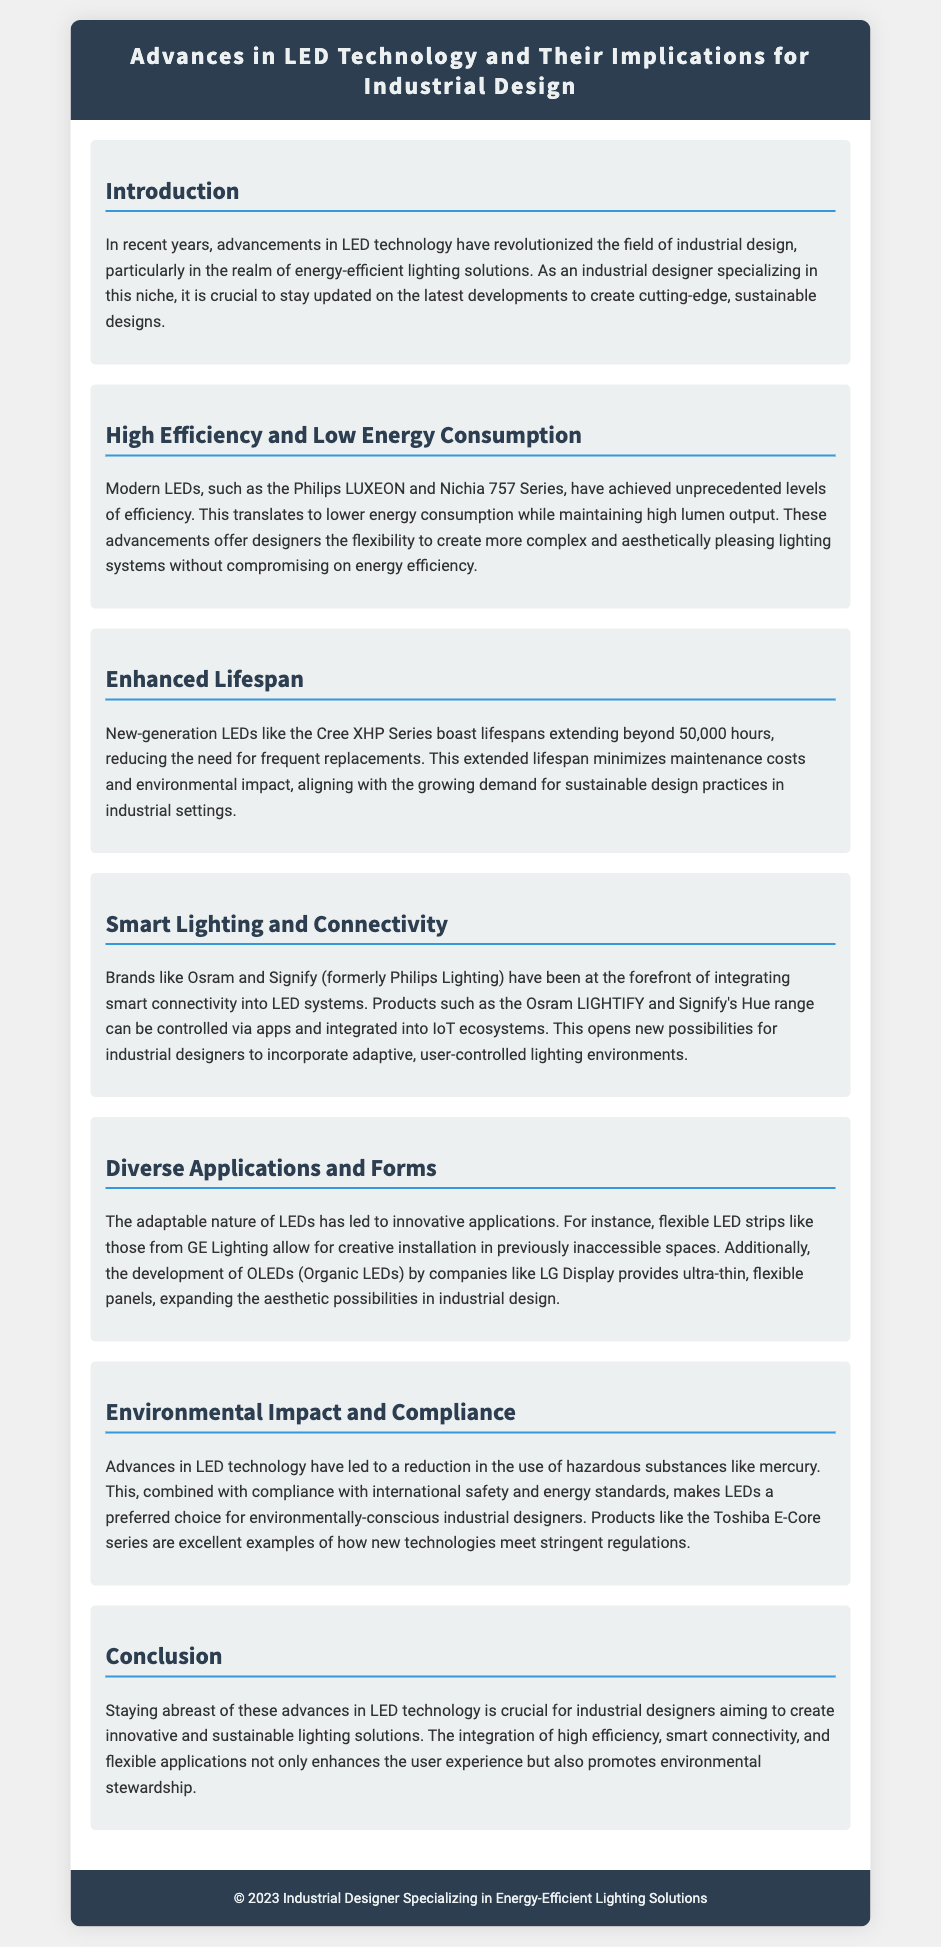What is the average lifespan of new-generation LEDs? The document states that new-generation LEDs like the Cree XHP Series boast lifespans extending beyond 50,000 hours.
Answer: 50,000 hours Which two brands are mentioned as leaders in smart lighting technology? The document mentions Osram and Signify (formerly Philips Lighting) as leaders in integrating smart connectivity into LED systems.
Answer: Osram and Signify What is a major environmental benefit of modern LEDs? The document highlights that advances in LED technology have led to a reduction in the use of hazardous substances like mercury.
Answer: Reduction of mercury What type of LED technology allows for creative installation in inaccessible spaces? The document mentions flexible LED strips from GE Lighting as a technology that allows for creative installation in previously inaccessible spaces.
Answer: Flexible LED strips What key feature of modern LEDs allows designers more aesthetic flexibility? The document indicates that modern LEDs, such as the Philips LUXEON and Nichia 757 Series, have achieved unprecedented levels of efficiency.
Answer: High efficiency 